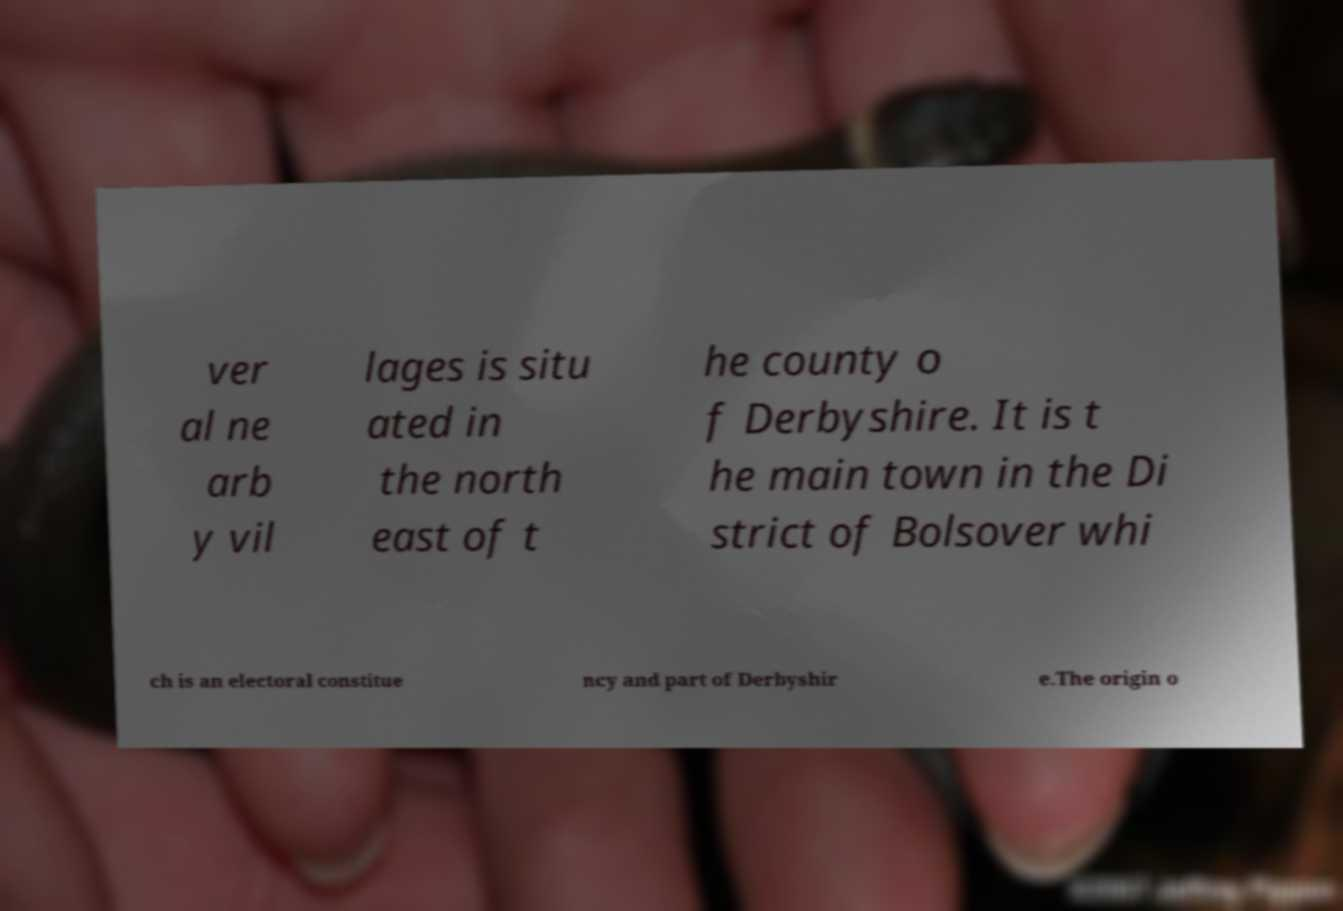What messages or text are displayed in this image? I need them in a readable, typed format. ver al ne arb y vil lages is situ ated in the north east of t he county o f Derbyshire. It is t he main town in the Di strict of Bolsover whi ch is an electoral constitue ncy and part of Derbyshir e.The origin o 